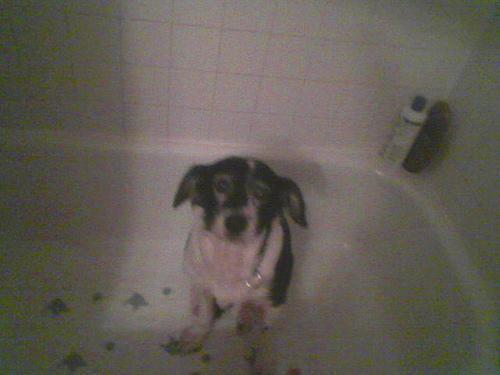How many wheels does the skateboard have?
Give a very brief answer. 0. 